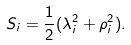Convert formula to latex. <formula><loc_0><loc_0><loc_500><loc_500>S _ { i } = \frac { 1 } { 2 } ( \lambda _ { i } ^ { 2 } + \rho _ { i } ^ { 2 } ) .</formula> 